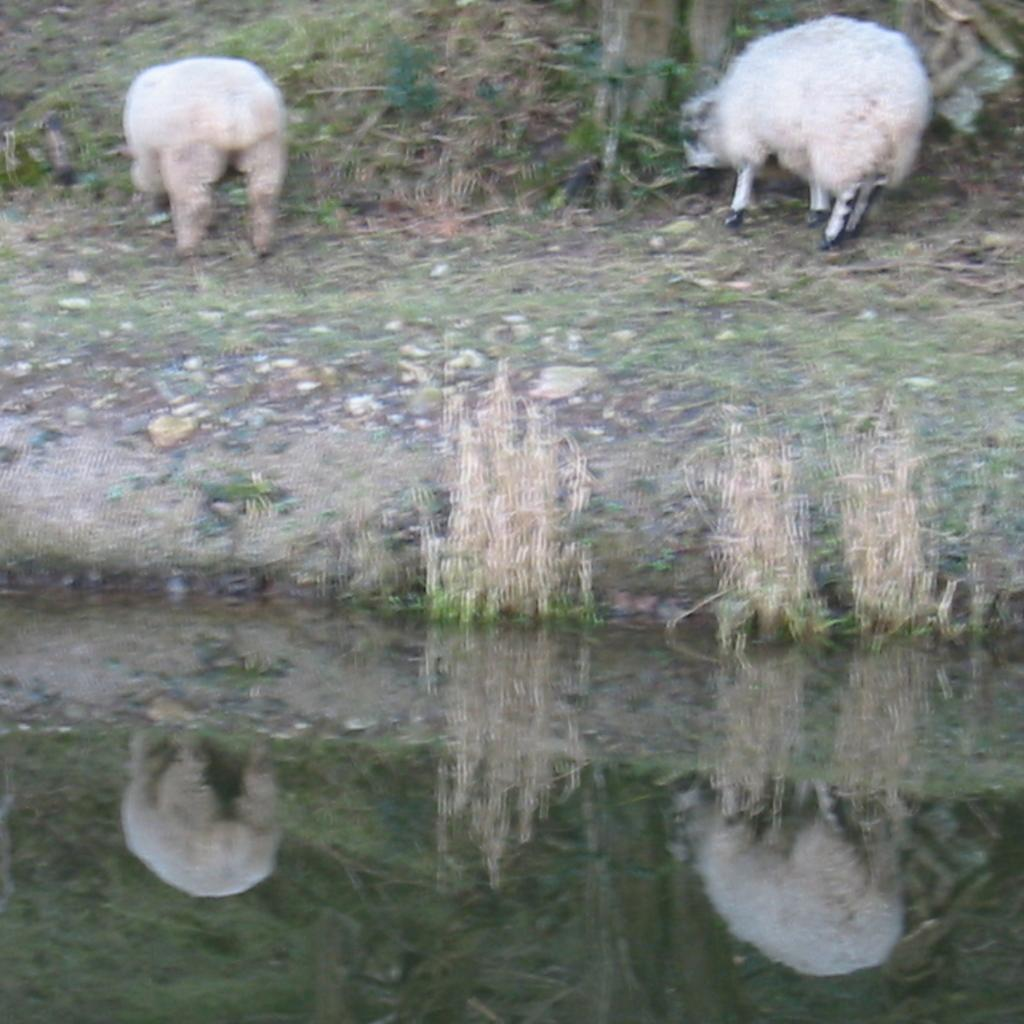What is the main feature in the foreground of the image? There is a water body in the foreground of the image. What can be seen in the background of the image? There are plants visible in the background of the image. What animals are present in the image? Two sheep are grazing in the image. Reasoning: Let' Let's think step by step in order to produce the conversation. We start by identifying the main feature in the foreground, which is the water body. Then, we describe the background, mentioning the presence of plants. Finally, we identify the animals in the image, which are two sheep. Each question is designed to elicit a specific detail about the image that is known from the provided facts. Absurd Question/Answer: What type of spoon can be seen floating in the water body? There is no spoon present in the image; it only features a water body, plants in the background, and two sheep grazing. What type of waves can be seen in the water body? There is no mention of waves in the image; it only features a water body, plants in the background, and two sheep grazing. 